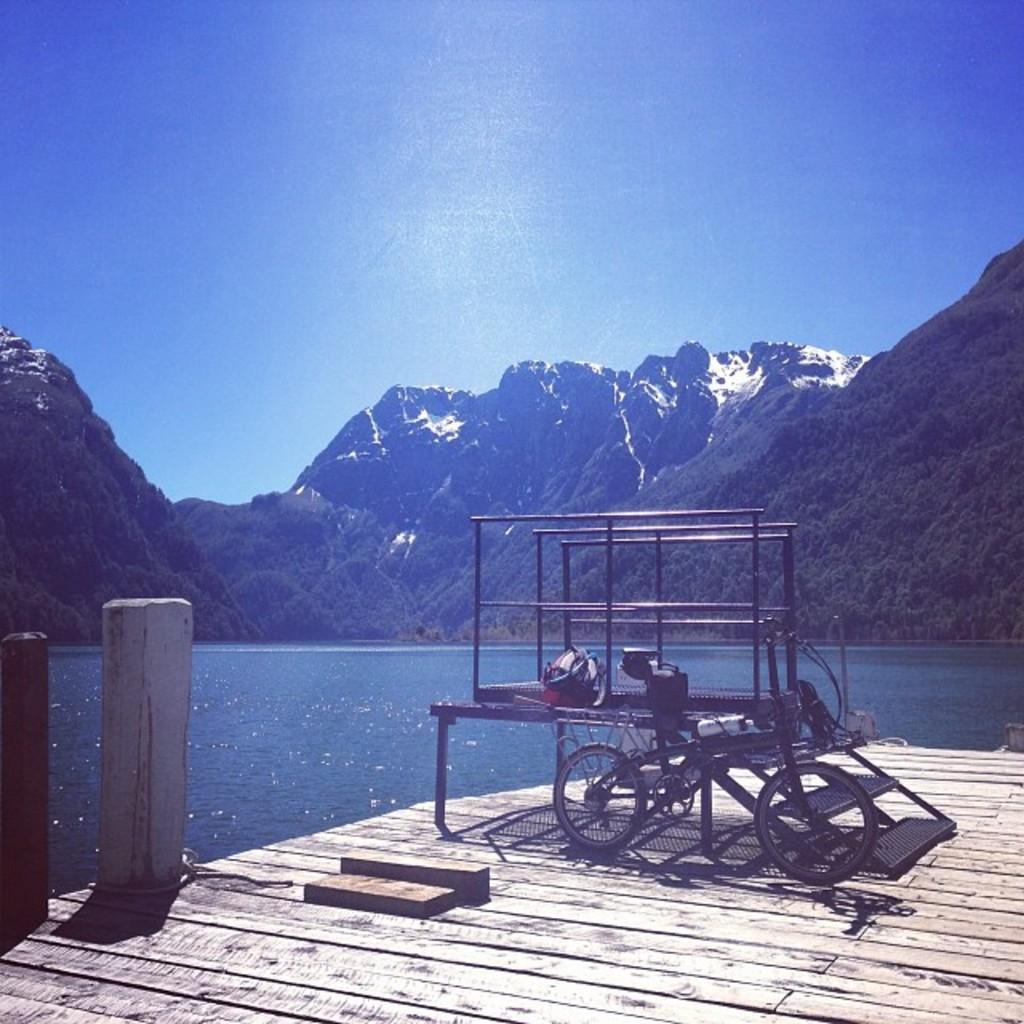Could you give a brief overview of what you see in this image? There is a black color object on a wooden surface and there are water and mountains in the background. 